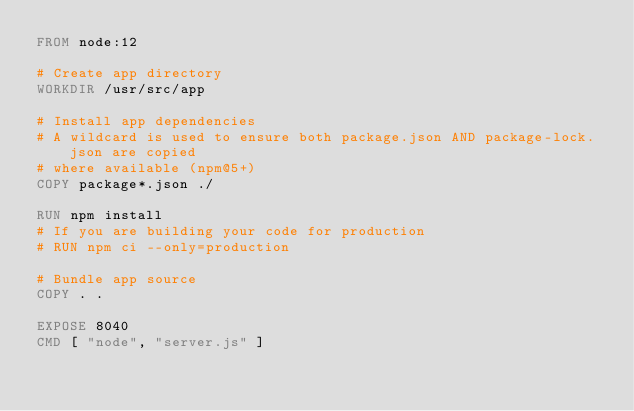Convert code to text. <code><loc_0><loc_0><loc_500><loc_500><_Dockerfile_>FROM node:12

# Create app directory
WORKDIR /usr/src/app

# Install app dependencies
# A wildcard is used to ensure both package.json AND package-lock.json are copied
# where available (npm@5+)
COPY package*.json ./

RUN npm install
# If you are building your code for production
# RUN npm ci --only=production

# Bundle app source
COPY . .

EXPOSE 8040
CMD [ "node", "server.js" ]
</code> 